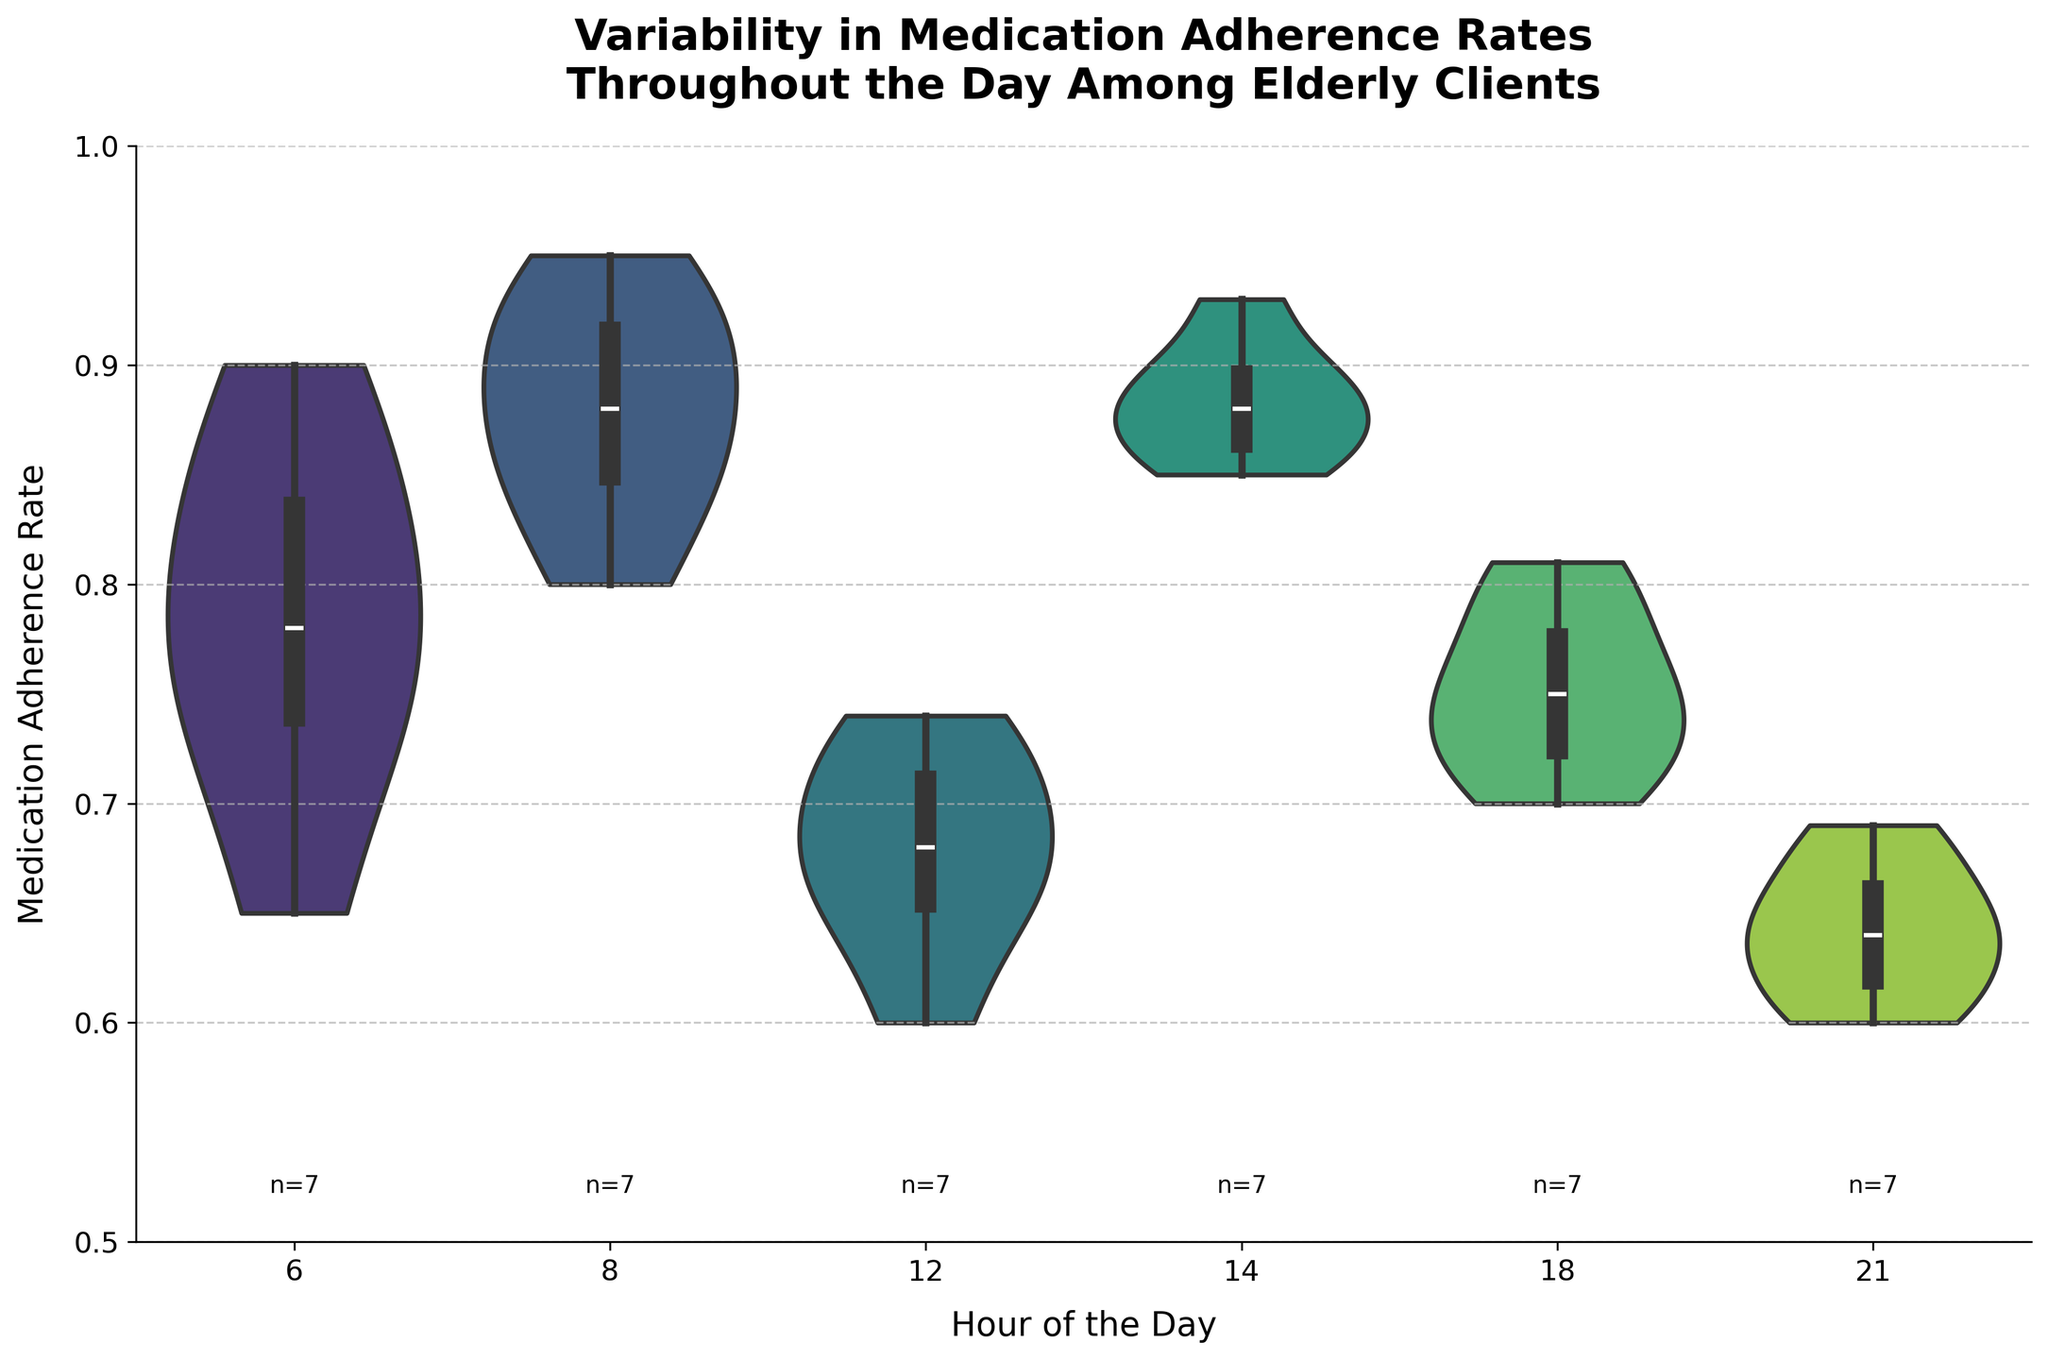What is the title of the figure? The title of the figure is prominently displayed at the top and summarizes the chart's content.
Answer: Variability in Medication Adherence Rates Throughout the Day Among Elderly Clients What are the axes labels in the figure? The x-axis label is at the bottom of the figure, and the y-axis label is along the left side.
Answer: Hour of the Day, Medication Adherence Rate Which hour has the highest median medication adherence rate? The median is represented by the white dot in each violin plot, and we compare the position of these dots.
Answer: 8 How many data points are there for the 6 AM hour? The number of data points for each hour is labeled below the x-axis.
Answer: 7 At what hour is the variability in medication adherence rate the largest? Larger variability in the violin plot is shown by a wider spread.
Answer: 12 What is the general trend in medication adherence throughout the day? Observing the median points, the rates generally decrease in the afternoon and evening.
Answer: Decrease Which hour has the smallest range of medication adherence rates? The range is shown by the height of the wider body of the violin plot.
Answer: 14 Compare the adherence rates at 6 AM and 8 AM. Which is higher? By comparing the widths and median points of the violin plots for 6 AM and 8 AM, we identify the higher rates.
Answer: 8 AM Which hour(s) show a decline in the adherence rate compared to the previous hour? By comparing consecutive violin plots, any downward shift in median points indicates a decline.
Answer: 12 PM, 6 PM, 9 PM During which hour is the lowest adherence rate observed? The lowest adherence rate is identified by the bottom extent of the violin plots.
Answer: 21 